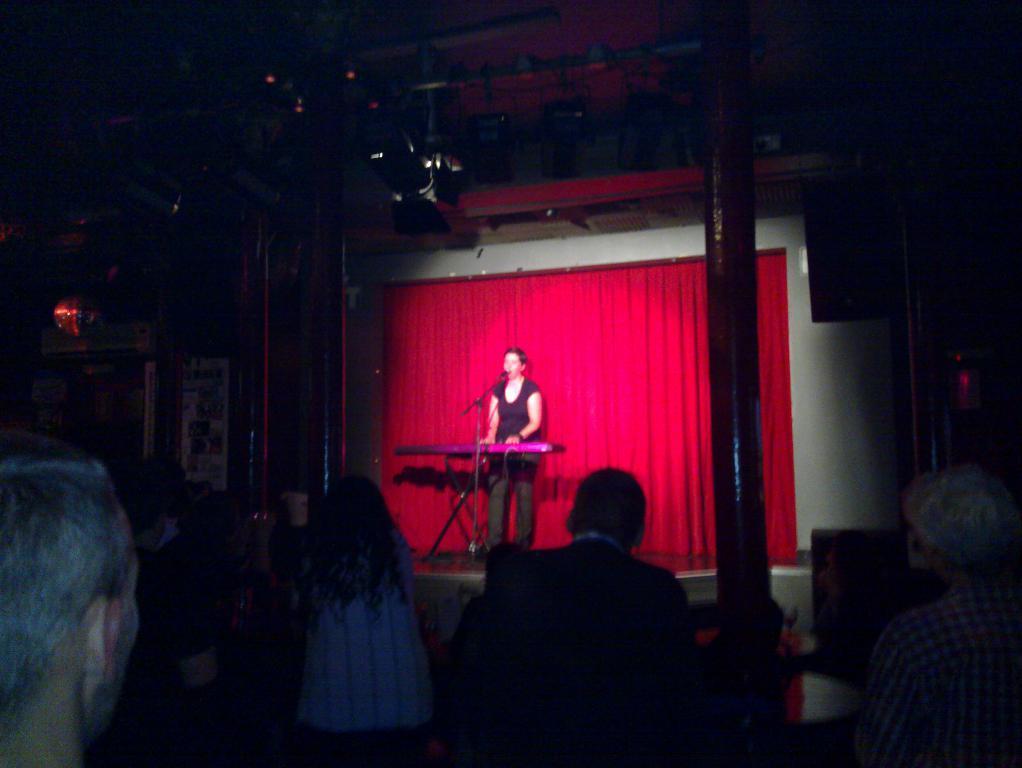In one or two sentences, can you explain what this image depicts? In this picture I can see few persons at the bottom, in the middle there is a woman, she is singing in the microphone. 